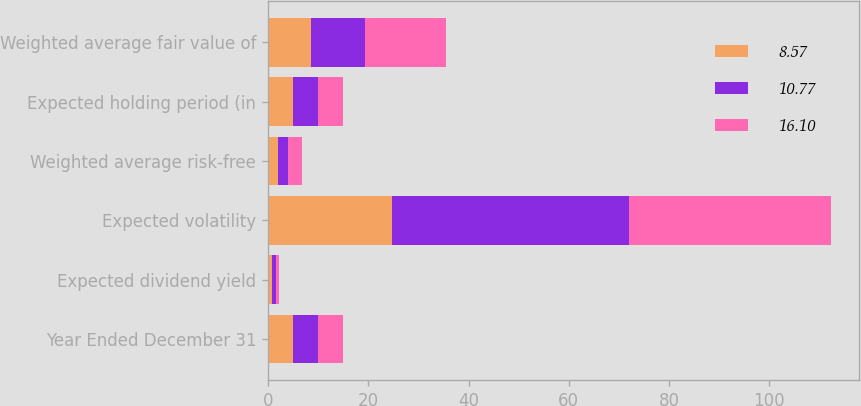<chart> <loc_0><loc_0><loc_500><loc_500><stacked_bar_chart><ecel><fcel>Year Ended December 31<fcel>Expected dividend yield<fcel>Expected volatility<fcel>Weighted average risk-free<fcel>Expected holding period (in<fcel>Weighted average fair value of<nl><fcel>8.57<fcel>5<fcel>0.7<fcel>24.7<fcel>2<fcel>5<fcel>8.57<nl><fcel>10.77<fcel>5<fcel>0.9<fcel>47.4<fcel>1.9<fcel>5<fcel>10.77<nl><fcel>16.1<fcel>5<fcel>0.6<fcel>40.2<fcel>2.9<fcel>5<fcel>16.1<nl></chart> 